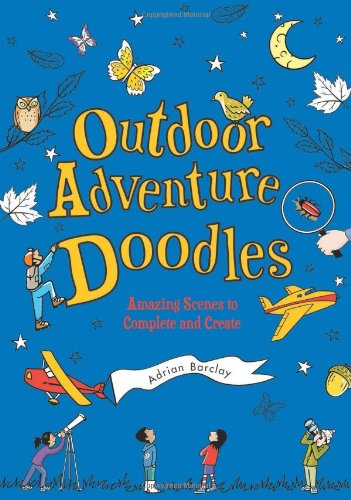Is this a kids book? Yes, this book is specifically targeted towards children, offering creatively structured activities that promote learning through art and play. 